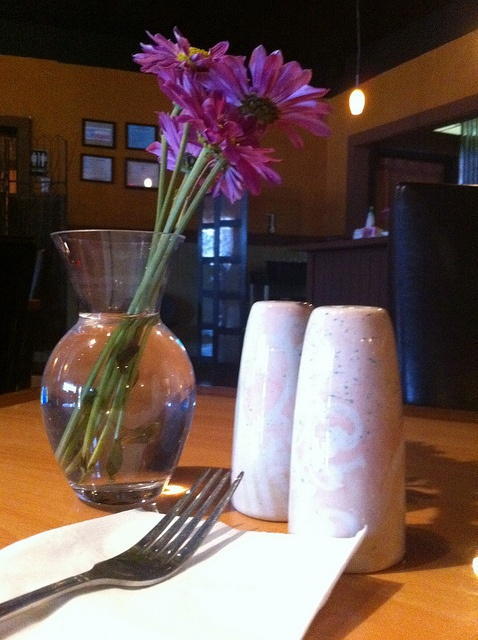Describe the objects in this image and their specific colors. I can see vase in black, gray, maroon, and brown tones, dining table in black, maroon, brown, and orange tones, fork in black, gray, white, and darkgray tones, and bottle in black, gray, and purple tones in this image. 